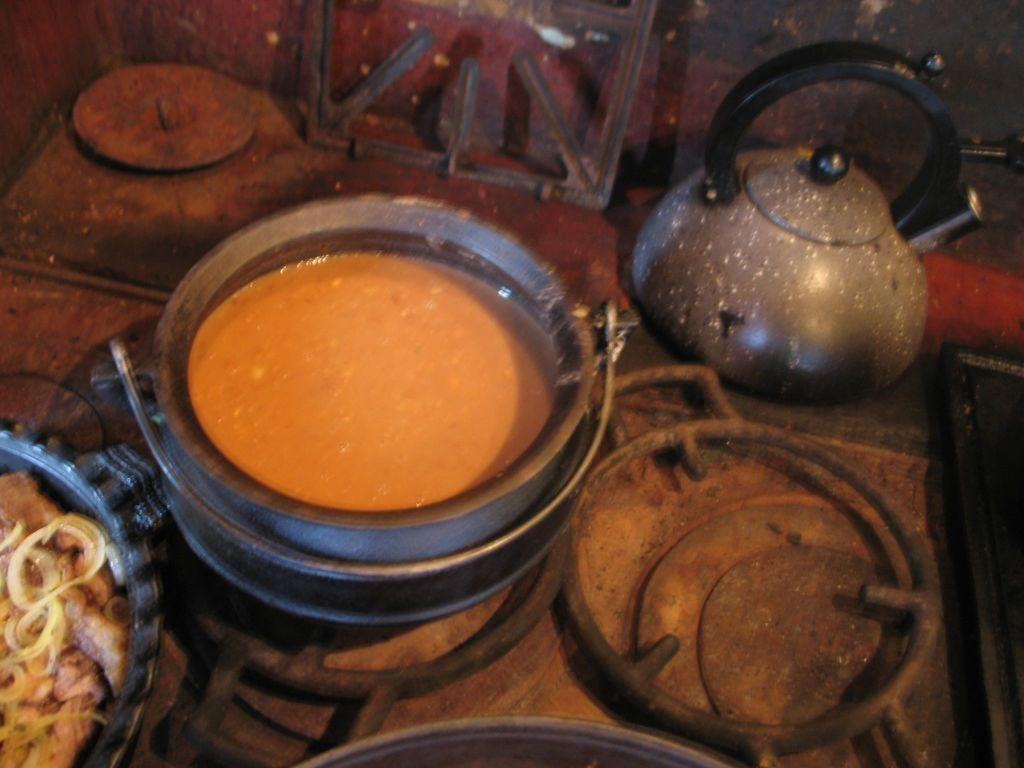What type of containers are present in the image? There are bowls in the image. What is inside the bowls? There are food items in the bowls. What material are the objects in the image made of? There are metal objects in the image. What shape is the pump in the image? There is no pump present in the image. 